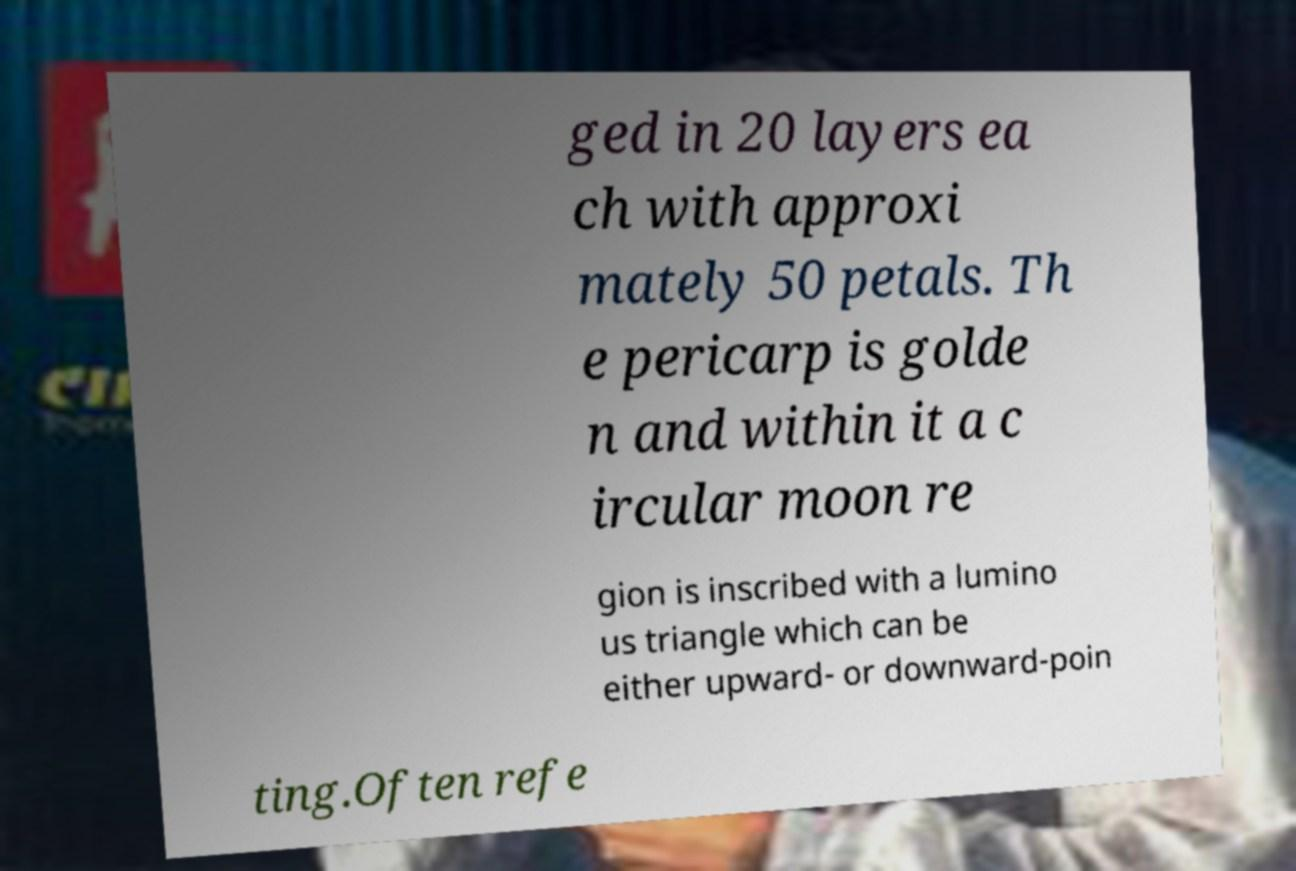Could you assist in decoding the text presented in this image and type it out clearly? ged in 20 layers ea ch with approxi mately 50 petals. Th e pericarp is golde n and within it a c ircular moon re gion is inscribed with a lumino us triangle which can be either upward- or downward-poin ting.Often refe 